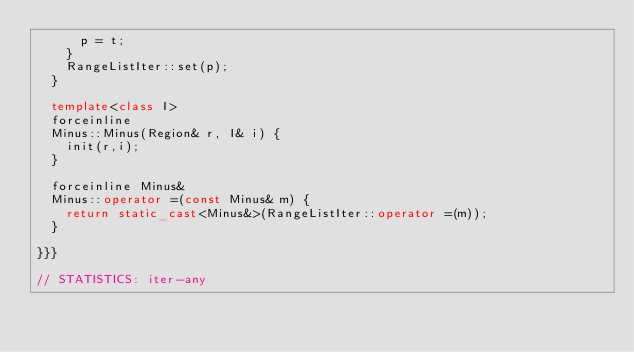<code> <loc_0><loc_0><loc_500><loc_500><_C++_>      p = t;
    }
    RangeListIter::set(p);
  }

  template<class I>
  forceinline
  Minus::Minus(Region& r, I& i) {
    init(r,i);
  }

  forceinline Minus&
  Minus::operator =(const Minus& m) {
    return static_cast<Minus&>(RangeListIter::operator =(m));
  }

}}}

// STATISTICS: iter-any

</code> 